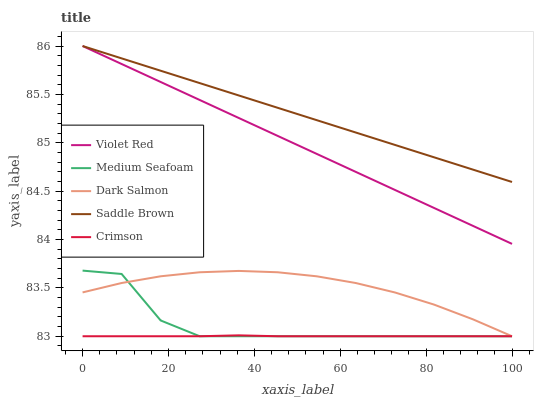Does Crimson have the minimum area under the curve?
Answer yes or no. Yes. Does Saddle Brown have the maximum area under the curve?
Answer yes or no. Yes. Does Violet Red have the minimum area under the curve?
Answer yes or no. No. Does Violet Red have the maximum area under the curve?
Answer yes or no. No. Is Violet Red the smoothest?
Answer yes or no. Yes. Is Medium Seafoam the roughest?
Answer yes or no. Yes. Is Crimson the smoothest?
Answer yes or no. No. Is Crimson the roughest?
Answer yes or no. No. Does Crimson have the lowest value?
Answer yes or no. Yes. Does Violet Red have the lowest value?
Answer yes or no. No. Does Violet Red have the highest value?
Answer yes or no. Yes. Does Crimson have the highest value?
Answer yes or no. No. Is Medium Seafoam less than Violet Red?
Answer yes or no. Yes. Is Violet Red greater than Dark Salmon?
Answer yes or no. Yes. Does Crimson intersect Medium Seafoam?
Answer yes or no. Yes. Is Crimson less than Medium Seafoam?
Answer yes or no. No. Is Crimson greater than Medium Seafoam?
Answer yes or no. No. Does Medium Seafoam intersect Violet Red?
Answer yes or no. No. 